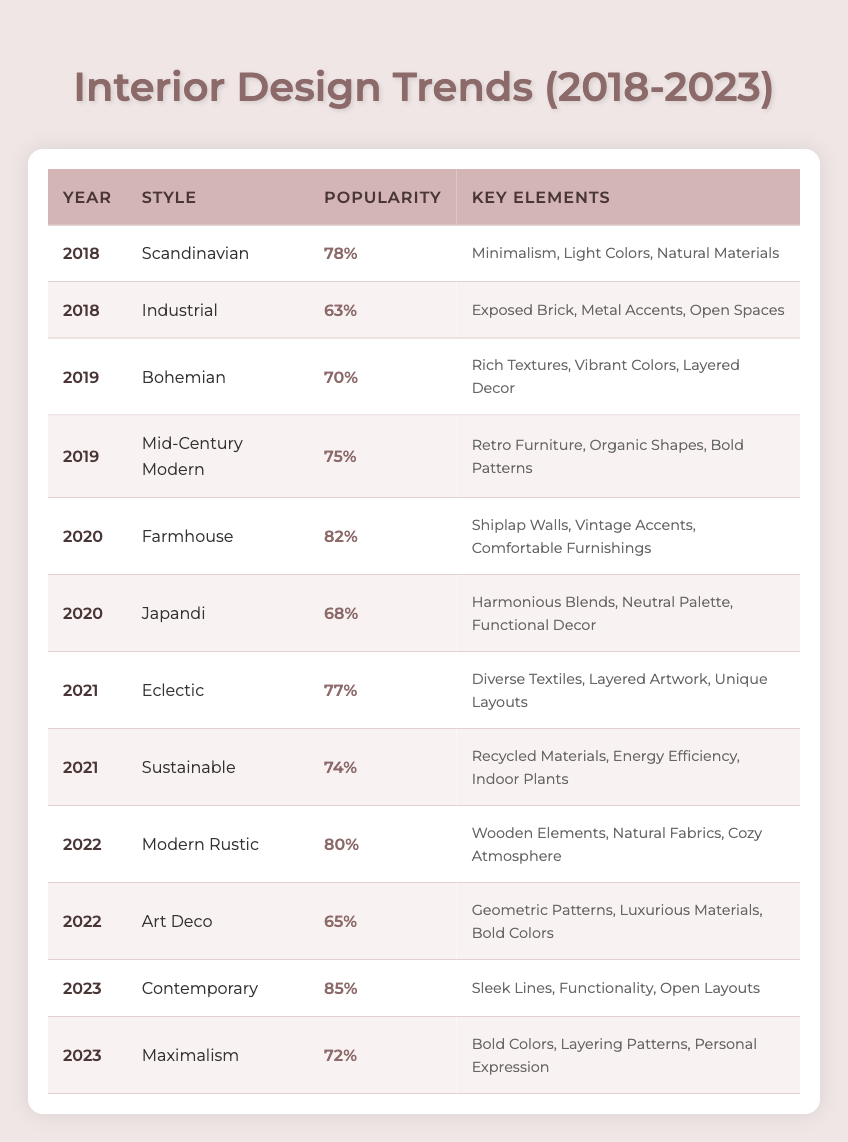What style had the highest popularity in 2021? The table shows the popularity of styles for each year. In 2021, the available styles are Eclectic (77%) and Sustainable (74%). Comparing these values, Eclectic has the highest popularity.
Answer: Eclectic What are the key elements of the Contemporary style for 2023? By looking at the row for the Contemporary style in 2023, the key elements listed are Sleek Lines, Functionality, and Open Layouts.
Answer: Sleek Lines, Functionality, Open Layouts How many styles had a popularity rating of 70% or higher in 2020? The styles in 2020 are Farmhouse (82%) and Japandi (68%). Only Farmhouse meets the requirement of being 70% or higher. Thus, there is one style.
Answer: 1 What was the average popularity of styles in 2019? The styles in 2019 are Bohemian (70%) and Mid-Century Modern (75%). To find the average, we add these values: 70 + 75 = 145, and then divide by 2, which gives us 145/2 = 72.5.
Answer: 72.5 Is Art Deco more popular than Modern Rustic in 2022? In 2022, Modern Rustic has a popularity of 80%, while Art Deco has a popularity of 65%. Since 80% is greater than 65%, the statement is true.
Answer: Yes Which style showed a decrease in popularity from 2018 to 2022? The styles available in 2018 are Scandinavian (78%) and Industrial (63%). In 2022, the styles are Modern Rustic (80%) and Art Deco (65%). Comparing trends, Scandinavian and Industrial are not available in 2022, but their popularity is higher in 2018 than Art Deco in 2022. Since there are no overlapping styles with decreased popularity, the answer is there is no style from 2018 to 2022 that showed a decrease.
Answer: No style What was the trend of popularity from 2018 to 2023? To find the trend, we look at the popularity ratings for each year: 2018 (78%), 2019 (70%, 75%), 2020 (82%, 68%), 2021 (77%, 74%), 2022 (80%, 65%), and 2023 (85%, 72%). Observing these ratings, there seems to be a fluctuation, but the overall trend shows an increase in popularity from 2020 and peaking in 2023.
Answer: Increasing How many styles were recorded in the year 2022? From the table, there are two styles for 2022: Modern Rustic and Art Deco. Therefore, the total number is two styles recorded for that year.
Answer: 2 What common theme do styles from 2018 and 2022 share based on their key elements? The styles from 2018 (Scandinavian, Industrial) focus on minimalism and functional characteristics, while the styles from 2022 (Modern Rustic, Art Deco) incorporate natural elements and comfort with some luxury, reflecting a blend in design philosophy. Therefore, both years emphasize the importance of design aesthetics and user comfort, even though they differ in specifics.
Answer: Focus on aesthetics and comfort 